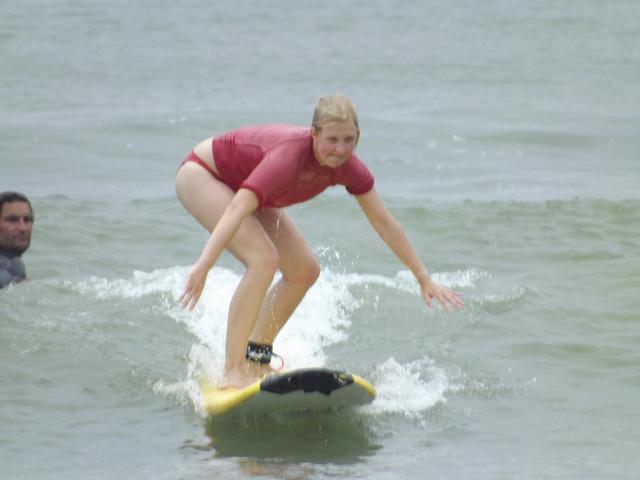How many people can you see?
Give a very brief answer. 2. How many skiiers are standing to the right of the train car?
Give a very brief answer. 0. 